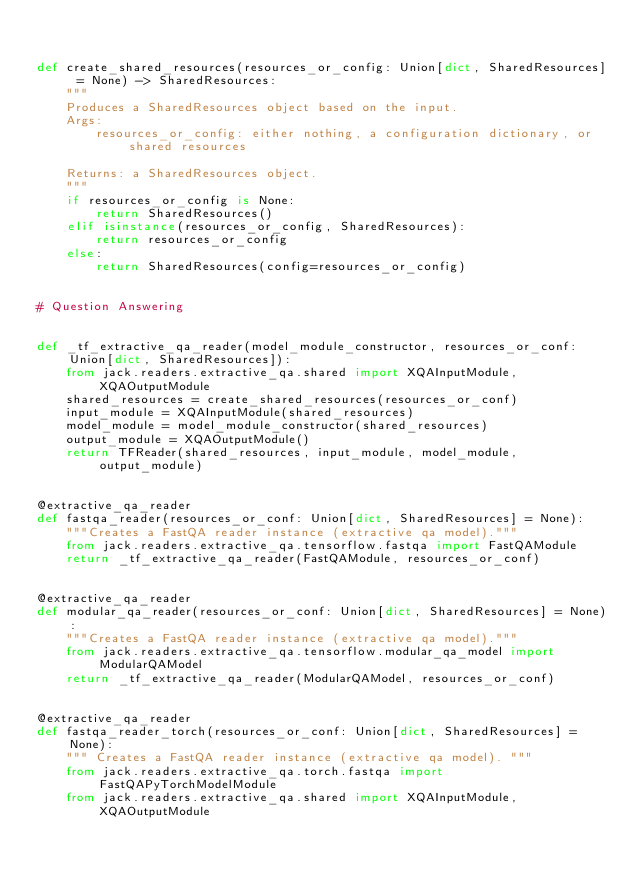<code> <loc_0><loc_0><loc_500><loc_500><_Python_>

def create_shared_resources(resources_or_config: Union[dict, SharedResources] = None) -> SharedResources:
    """
    Produces a SharedResources object based on the input.
    Args:
        resources_or_config: either nothing, a configuration dictionary, or shared resources

    Returns: a SharedResources object.
    """
    if resources_or_config is None:
        return SharedResources()
    elif isinstance(resources_or_config, SharedResources):
        return resources_or_config
    else:
        return SharedResources(config=resources_or_config)


# Question Answering


def _tf_extractive_qa_reader(model_module_constructor, resources_or_conf: Union[dict, SharedResources]):
    from jack.readers.extractive_qa.shared import XQAInputModule, XQAOutputModule
    shared_resources = create_shared_resources(resources_or_conf)
    input_module = XQAInputModule(shared_resources)
    model_module = model_module_constructor(shared_resources)
    output_module = XQAOutputModule()
    return TFReader(shared_resources, input_module, model_module, output_module)


@extractive_qa_reader
def fastqa_reader(resources_or_conf: Union[dict, SharedResources] = None):
    """Creates a FastQA reader instance (extractive qa model)."""
    from jack.readers.extractive_qa.tensorflow.fastqa import FastQAModule
    return _tf_extractive_qa_reader(FastQAModule, resources_or_conf)


@extractive_qa_reader
def modular_qa_reader(resources_or_conf: Union[dict, SharedResources] = None):
    """Creates a FastQA reader instance (extractive qa model)."""
    from jack.readers.extractive_qa.tensorflow.modular_qa_model import ModularQAModel
    return _tf_extractive_qa_reader(ModularQAModel, resources_or_conf)


@extractive_qa_reader
def fastqa_reader_torch(resources_or_conf: Union[dict, SharedResources] = None):
    """ Creates a FastQA reader instance (extractive qa model). """
    from jack.readers.extractive_qa.torch.fastqa import FastQAPyTorchModelModule
    from jack.readers.extractive_qa.shared import XQAInputModule, XQAOutputModule</code> 